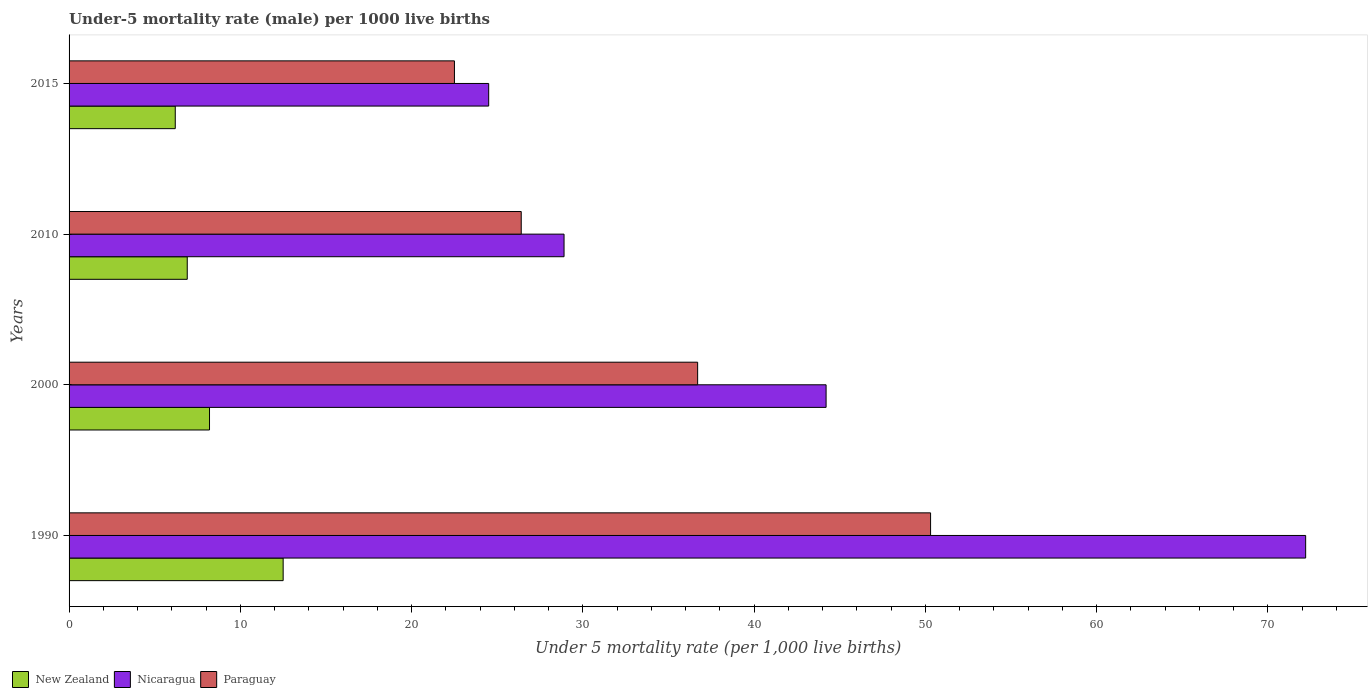How many groups of bars are there?
Ensure brevity in your answer.  4. How many bars are there on the 3rd tick from the top?
Your answer should be very brief. 3. Across all years, what is the maximum under-five mortality rate in Nicaragua?
Ensure brevity in your answer.  72.2. Across all years, what is the minimum under-five mortality rate in New Zealand?
Your answer should be very brief. 6.2. In which year was the under-five mortality rate in Nicaragua minimum?
Make the answer very short. 2015. What is the total under-five mortality rate in Nicaragua in the graph?
Offer a very short reply. 169.8. What is the difference between the under-five mortality rate in New Zealand in 1990 and that in 2010?
Make the answer very short. 5.6. What is the difference between the under-five mortality rate in Paraguay in 1990 and the under-five mortality rate in Nicaragua in 2015?
Keep it short and to the point. 25.8. What is the average under-five mortality rate in Paraguay per year?
Your answer should be compact. 33.98. In the year 2000, what is the difference between the under-five mortality rate in Nicaragua and under-five mortality rate in Paraguay?
Your response must be concise. 7.5. In how many years, is the under-five mortality rate in Paraguay greater than 54 ?
Offer a very short reply. 0. What is the ratio of the under-five mortality rate in Nicaragua in 2010 to that in 2015?
Keep it short and to the point. 1.18. Is the difference between the under-five mortality rate in Nicaragua in 1990 and 2000 greater than the difference between the under-five mortality rate in Paraguay in 1990 and 2000?
Offer a very short reply. Yes. What is the difference between the highest and the second highest under-five mortality rate in Paraguay?
Offer a terse response. 13.6. What is the difference between the highest and the lowest under-five mortality rate in Paraguay?
Offer a terse response. 27.8. In how many years, is the under-five mortality rate in Nicaragua greater than the average under-five mortality rate in Nicaragua taken over all years?
Offer a terse response. 2. What does the 2nd bar from the top in 2000 represents?
Ensure brevity in your answer.  Nicaragua. What does the 2nd bar from the bottom in 2010 represents?
Provide a succinct answer. Nicaragua. How many bars are there?
Your answer should be compact. 12. Are all the bars in the graph horizontal?
Make the answer very short. Yes. How many years are there in the graph?
Your answer should be compact. 4. Does the graph contain any zero values?
Provide a succinct answer. No. Does the graph contain grids?
Offer a very short reply. No. Where does the legend appear in the graph?
Provide a short and direct response. Bottom left. How are the legend labels stacked?
Make the answer very short. Horizontal. What is the title of the graph?
Make the answer very short. Under-5 mortality rate (male) per 1000 live births. Does "Djibouti" appear as one of the legend labels in the graph?
Provide a succinct answer. No. What is the label or title of the X-axis?
Offer a very short reply. Under 5 mortality rate (per 1,0 live births). What is the Under 5 mortality rate (per 1,000 live births) in New Zealand in 1990?
Your answer should be compact. 12.5. What is the Under 5 mortality rate (per 1,000 live births) of Nicaragua in 1990?
Offer a terse response. 72.2. What is the Under 5 mortality rate (per 1,000 live births) of Paraguay in 1990?
Provide a short and direct response. 50.3. What is the Under 5 mortality rate (per 1,000 live births) in Nicaragua in 2000?
Your answer should be compact. 44.2. What is the Under 5 mortality rate (per 1,000 live births) of Paraguay in 2000?
Give a very brief answer. 36.7. What is the Under 5 mortality rate (per 1,000 live births) of New Zealand in 2010?
Your answer should be compact. 6.9. What is the Under 5 mortality rate (per 1,000 live births) of Nicaragua in 2010?
Your response must be concise. 28.9. What is the Under 5 mortality rate (per 1,000 live births) of Paraguay in 2010?
Give a very brief answer. 26.4. What is the Under 5 mortality rate (per 1,000 live births) in Paraguay in 2015?
Ensure brevity in your answer.  22.5. Across all years, what is the maximum Under 5 mortality rate (per 1,000 live births) in Nicaragua?
Offer a very short reply. 72.2. Across all years, what is the maximum Under 5 mortality rate (per 1,000 live births) in Paraguay?
Your answer should be very brief. 50.3. Across all years, what is the minimum Under 5 mortality rate (per 1,000 live births) in New Zealand?
Your answer should be compact. 6.2. Across all years, what is the minimum Under 5 mortality rate (per 1,000 live births) in Nicaragua?
Keep it short and to the point. 24.5. Across all years, what is the minimum Under 5 mortality rate (per 1,000 live births) in Paraguay?
Offer a very short reply. 22.5. What is the total Under 5 mortality rate (per 1,000 live births) of New Zealand in the graph?
Make the answer very short. 33.8. What is the total Under 5 mortality rate (per 1,000 live births) of Nicaragua in the graph?
Provide a short and direct response. 169.8. What is the total Under 5 mortality rate (per 1,000 live births) of Paraguay in the graph?
Your response must be concise. 135.9. What is the difference between the Under 5 mortality rate (per 1,000 live births) in Paraguay in 1990 and that in 2000?
Keep it short and to the point. 13.6. What is the difference between the Under 5 mortality rate (per 1,000 live births) in Nicaragua in 1990 and that in 2010?
Ensure brevity in your answer.  43.3. What is the difference between the Under 5 mortality rate (per 1,000 live births) of Paraguay in 1990 and that in 2010?
Your answer should be very brief. 23.9. What is the difference between the Under 5 mortality rate (per 1,000 live births) of New Zealand in 1990 and that in 2015?
Offer a very short reply. 6.3. What is the difference between the Under 5 mortality rate (per 1,000 live births) of Nicaragua in 1990 and that in 2015?
Offer a terse response. 47.7. What is the difference between the Under 5 mortality rate (per 1,000 live births) in Paraguay in 1990 and that in 2015?
Make the answer very short. 27.8. What is the difference between the Under 5 mortality rate (per 1,000 live births) of Paraguay in 2000 and that in 2010?
Keep it short and to the point. 10.3. What is the difference between the Under 5 mortality rate (per 1,000 live births) in Nicaragua in 2000 and that in 2015?
Your answer should be very brief. 19.7. What is the difference between the Under 5 mortality rate (per 1,000 live births) in Paraguay in 2000 and that in 2015?
Provide a short and direct response. 14.2. What is the difference between the Under 5 mortality rate (per 1,000 live births) of Nicaragua in 2010 and that in 2015?
Your answer should be compact. 4.4. What is the difference between the Under 5 mortality rate (per 1,000 live births) of Paraguay in 2010 and that in 2015?
Keep it short and to the point. 3.9. What is the difference between the Under 5 mortality rate (per 1,000 live births) in New Zealand in 1990 and the Under 5 mortality rate (per 1,000 live births) in Nicaragua in 2000?
Your response must be concise. -31.7. What is the difference between the Under 5 mortality rate (per 1,000 live births) in New Zealand in 1990 and the Under 5 mortality rate (per 1,000 live births) in Paraguay in 2000?
Your response must be concise. -24.2. What is the difference between the Under 5 mortality rate (per 1,000 live births) in Nicaragua in 1990 and the Under 5 mortality rate (per 1,000 live births) in Paraguay in 2000?
Keep it short and to the point. 35.5. What is the difference between the Under 5 mortality rate (per 1,000 live births) of New Zealand in 1990 and the Under 5 mortality rate (per 1,000 live births) of Nicaragua in 2010?
Offer a terse response. -16.4. What is the difference between the Under 5 mortality rate (per 1,000 live births) of Nicaragua in 1990 and the Under 5 mortality rate (per 1,000 live births) of Paraguay in 2010?
Your response must be concise. 45.8. What is the difference between the Under 5 mortality rate (per 1,000 live births) of Nicaragua in 1990 and the Under 5 mortality rate (per 1,000 live births) of Paraguay in 2015?
Offer a terse response. 49.7. What is the difference between the Under 5 mortality rate (per 1,000 live births) of New Zealand in 2000 and the Under 5 mortality rate (per 1,000 live births) of Nicaragua in 2010?
Provide a short and direct response. -20.7. What is the difference between the Under 5 mortality rate (per 1,000 live births) in New Zealand in 2000 and the Under 5 mortality rate (per 1,000 live births) in Paraguay in 2010?
Your response must be concise. -18.2. What is the difference between the Under 5 mortality rate (per 1,000 live births) in Nicaragua in 2000 and the Under 5 mortality rate (per 1,000 live births) in Paraguay in 2010?
Offer a very short reply. 17.8. What is the difference between the Under 5 mortality rate (per 1,000 live births) in New Zealand in 2000 and the Under 5 mortality rate (per 1,000 live births) in Nicaragua in 2015?
Provide a succinct answer. -16.3. What is the difference between the Under 5 mortality rate (per 1,000 live births) in New Zealand in 2000 and the Under 5 mortality rate (per 1,000 live births) in Paraguay in 2015?
Offer a terse response. -14.3. What is the difference between the Under 5 mortality rate (per 1,000 live births) of Nicaragua in 2000 and the Under 5 mortality rate (per 1,000 live births) of Paraguay in 2015?
Your answer should be very brief. 21.7. What is the difference between the Under 5 mortality rate (per 1,000 live births) of New Zealand in 2010 and the Under 5 mortality rate (per 1,000 live births) of Nicaragua in 2015?
Provide a short and direct response. -17.6. What is the difference between the Under 5 mortality rate (per 1,000 live births) of New Zealand in 2010 and the Under 5 mortality rate (per 1,000 live births) of Paraguay in 2015?
Give a very brief answer. -15.6. What is the difference between the Under 5 mortality rate (per 1,000 live births) in Nicaragua in 2010 and the Under 5 mortality rate (per 1,000 live births) in Paraguay in 2015?
Keep it short and to the point. 6.4. What is the average Under 5 mortality rate (per 1,000 live births) of New Zealand per year?
Offer a very short reply. 8.45. What is the average Under 5 mortality rate (per 1,000 live births) in Nicaragua per year?
Your answer should be very brief. 42.45. What is the average Under 5 mortality rate (per 1,000 live births) of Paraguay per year?
Provide a short and direct response. 33.98. In the year 1990, what is the difference between the Under 5 mortality rate (per 1,000 live births) of New Zealand and Under 5 mortality rate (per 1,000 live births) of Nicaragua?
Offer a very short reply. -59.7. In the year 1990, what is the difference between the Under 5 mortality rate (per 1,000 live births) in New Zealand and Under 5 mortality rate (per 1,000 live births) in Paraguay?
Ensure brevity in your answer.  -37.8. In the year 1990, what is the difference between the Under 5 mortality rate (per 1,000 live births) in Nicaragua and Under 5 mortality rate (per 1,000 live births) in Paraguay?
Your response must be concise. 21.9. In the year 2000, what is the difference between the Under 5 mortality rate (per 1,000 live births) of New Zealand and Under 5 mortality rate (per 1,000 live births) of Nicaragua?
Offer a very short reply. -36. In the year 2000, what is the difference between the Under 5 mortality rate (per 1,000 live births) of New Zealand and Under 5 mortality rate (per 1,000 live births) of Paraguay?
Keep it short and to the point. -28.5. In the year 2010, what is the difference between the Under 5 mortality rate (per 1,000 live births) in New Zealand and Under 5 mortality rate (per 1,000 live births) in Nicaragua?
Your answer should be very brief. -22. In the year 2010, what is the difference between the Under 5 mortality rate (per 1,000 live births) of New Zealand and Under 5 mortality rate (per 1,000 live births) of Paraguay?
Ensure brevity in your answer.  -19.5. In the year 2010, what is the difference between the Under 5 mortality rate (per 1,000 live births) of Nicaragua and Under 5 mortality rate (per 1,000 live births) of Paraguay?
Offer a very short reply. 2.5. In the year 2015, what is the difference between the Under 5 mortality rate (per 1,000 live births) of New Zealand and Under 5 mortality rate (per 1,000 live births) of Nicaragua?
Give a very brief answer. -18.3. In the year 2015, what is the difference between the Under 5 mortality rate (per 1,000 live births) of New Zealand and Under 5 mortality rate (per 1,000 live births) of Paraguay?
Offer a very short reply. -16.3. What is the ratio of the Under 5 mortality rate (per 1,000 live births) in New Zealand in 1990 to that in 2000?
Make the answer very short. 1.52. What is the ratio of the Under 5 mortality rate (per 1,000 live births) in Nicaragua in 1990 to that in 2000?
Your response must be concise. 1.63. What is the ratio of the Under 5 mortality rate (per 1,000 live births) in Paraguay in 1990 to that in 2000?
Keep it short and to the point. 1.37. What is the ratio of the Under 5 mortality rate (per 1,000 live births) in New Zealand in 1990 to that in 2010?
Offer a terse response. 1.81. What is the ratio of the Under 5 mortality rate (per 1,000 live births) in Nicaragua in 1990 to that in 2010?
Your response must be concise. 2.5. What is the ratio of the Under 5 mortality rate (per 1,000 live births) of Paraguay in 1990 to that in 2010?
Provide a short and direct response. 1.91. What is the ratio of the Under 5 mortality rate (per 1,000 live births) of New Zealand in 1990 to that in 2015?
Give a very brief answer. 2.02. What is the ratio of the Under 5 mortality rate (per 1,000 live births) of Nicaragua in 1990 to that in 2015?
Make the answer very short. 2.95. What is the ratio of the Under 5 mortality rate (per 1,000 live births) of Paraguay in 1990 to that in 2015?
Offer a terse response. 2.24. What is the ratio of the Under 5 mortality rate (per 1,000 live births) of New Zealand in 2000 to that in 2010?
Offer a terse response. 1.19. What is the ratio of the Under 5 mortality rate (per 1,000 live births) of Nicaragua in 2000 to that in 2010?
Offer a very short reply. 1.53. What is the ratio of the Under 5 mortality rate (per 1,000 live births) of Paraguay in 2000 to that in 2010?
Make the answer very short. 1.39. What is the ratio of the Under 5 mortality rate (per 1,000 live births) in New Zealand in 2000 to that in 2015?
Your answer should be very brief. 1.32. What is the ratio of the Under 5 mortality rate (per 1,000 live births) in Nicaragua in 2000 to that in 2015?
Your answer should be compact. 1.8. What is the ratio of the Under 5 mortality rate (per 1,000 live births) of Paraguay in 2000 to that in 2015?
Ensure brevity in your answer.  1.63. What is the ratio of the Under 5 mortality rate (per 1,000 live births) of New Zealand in 2010 to that in 2015?
Your answer should be compact. 1.11. What is the ratio of the Under 5 mortality rate (per 1,000 live births) of Nicaragua in 2010 to that in 2015?
Provide a succinct answer. 1.18. What is the ratio of the Under 5 mortality rate (per 1,000 live births) of Paraguay in 2010 to that in 2015?
Offer a very short reply. 1.17. What is the difference between the highest and the second highest Under 5 mortality rate (per 1,000 live births) of New Zealand?
Ensure brevity in your answer.  4.3. What is the difference between the highest and the second highest Under 5 mortality rate (per 1,000 live births) of Nicaragua?
Give a very brief answer. 28. What is the difference between the highest and the second highest Under 5 mortality rate (per 1,000 live births) in Paraguay?
Give a very brief answer. 13.6. What is the difference between the highest and the lowest Under 5 mortality rate (per 1,000 live births) of Nicaragua?
Give a very brief answer. 47.7. What is the difference between the highest and the lowest Under 5 mortality rate (per 1,000 live births) of Paraguay?
Provide a succinct answer. 27.8. 